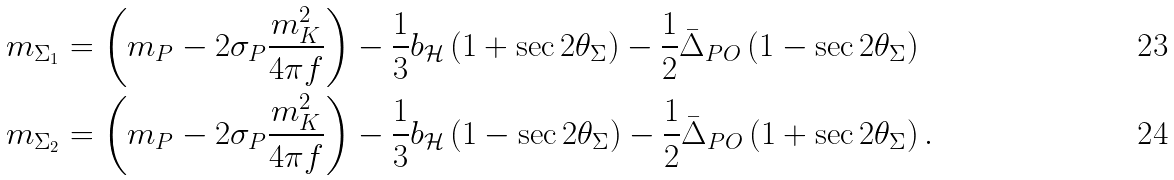<formula> <loc_0><loc_0><loc_500><loc_500>m _ { \Sigma _ { 1 } } & = \left ( m _ { P } - 2 \sigma _ { P } \frac { m _ { K } ^ { 2 } } { 4 \pi f } \right ) - \frac { 1 } { 3 } b _ { \mathcal { H } } \left ( 1 + \sec { 2 \theta _ { \Sigma } } \right ) - \frac { 1 } { 2 } \bar { \Delta } _ { P O } \left ( 1 - \sec { 2 \theta _ { \Sigma } } \right ) \\ m _ { \Sigma _ { 2 } } & = \left ( m _ { P } - 2 \sigma _ { P } \frac { m _ { K } ^ { 2 } } { 4 \pi f } \right ) - \frac { 1 } { 3 } b _ { \mathcal { H } } \left ( 1 - \sec { 2 \theta _ { \Sigma } } \right ) - \frac { 1 } { 2 } \bar { \Delta } _ { P O } \left ( 1 + \sec { 2 \theta _ { \Sigma } } \right ) .</formula> 